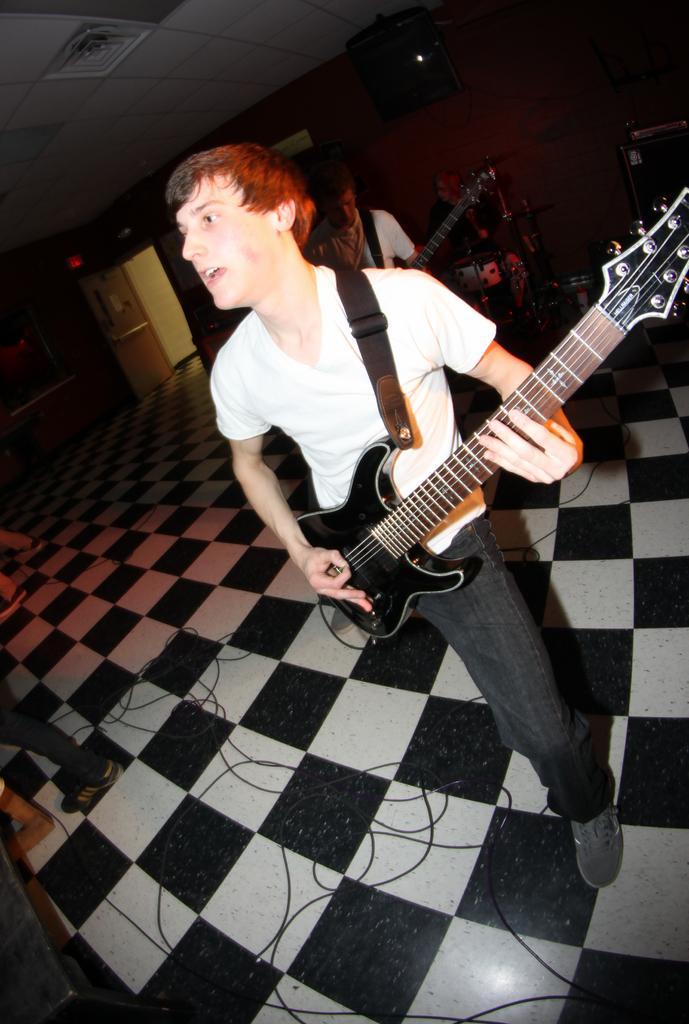Describe this image in one or two sentences. In this image i can see a man playing guitar at the back ground i can see few other person playing some musical instrument and a wall. 